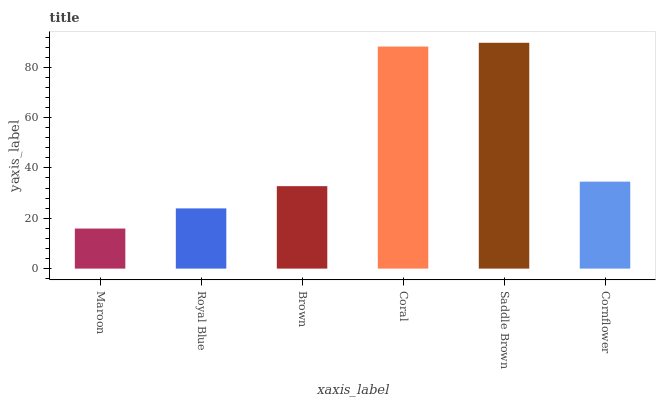Is Maroon the minimum?
Answer yes or no. Yes. Is Saddle Brown the maximum?
Answer yes or no. Yes. Is Royal Blue the minimum?
Answer yes or no. No. Is Royal Blue the maximum?
Answer yes or no. No. Is Royal Blue greater than Maroon?
Answer yes or no. Yes. Is Maroon less than Royal Blue?
Answer yes or no. Yes. Is Maroon greater than Royal Blue?
Answer yes or no. No. Is Royal Blue less than Maroon?
Answer yes or no. No. Is Cornflower the high median?
Answer yes or no. Yes. Is Brown the low median?
Answer yes or no. Yes. Is Coral the high median?
Answer yes or no. No. Is Maroon the low median?
Answer yes or no. No. 